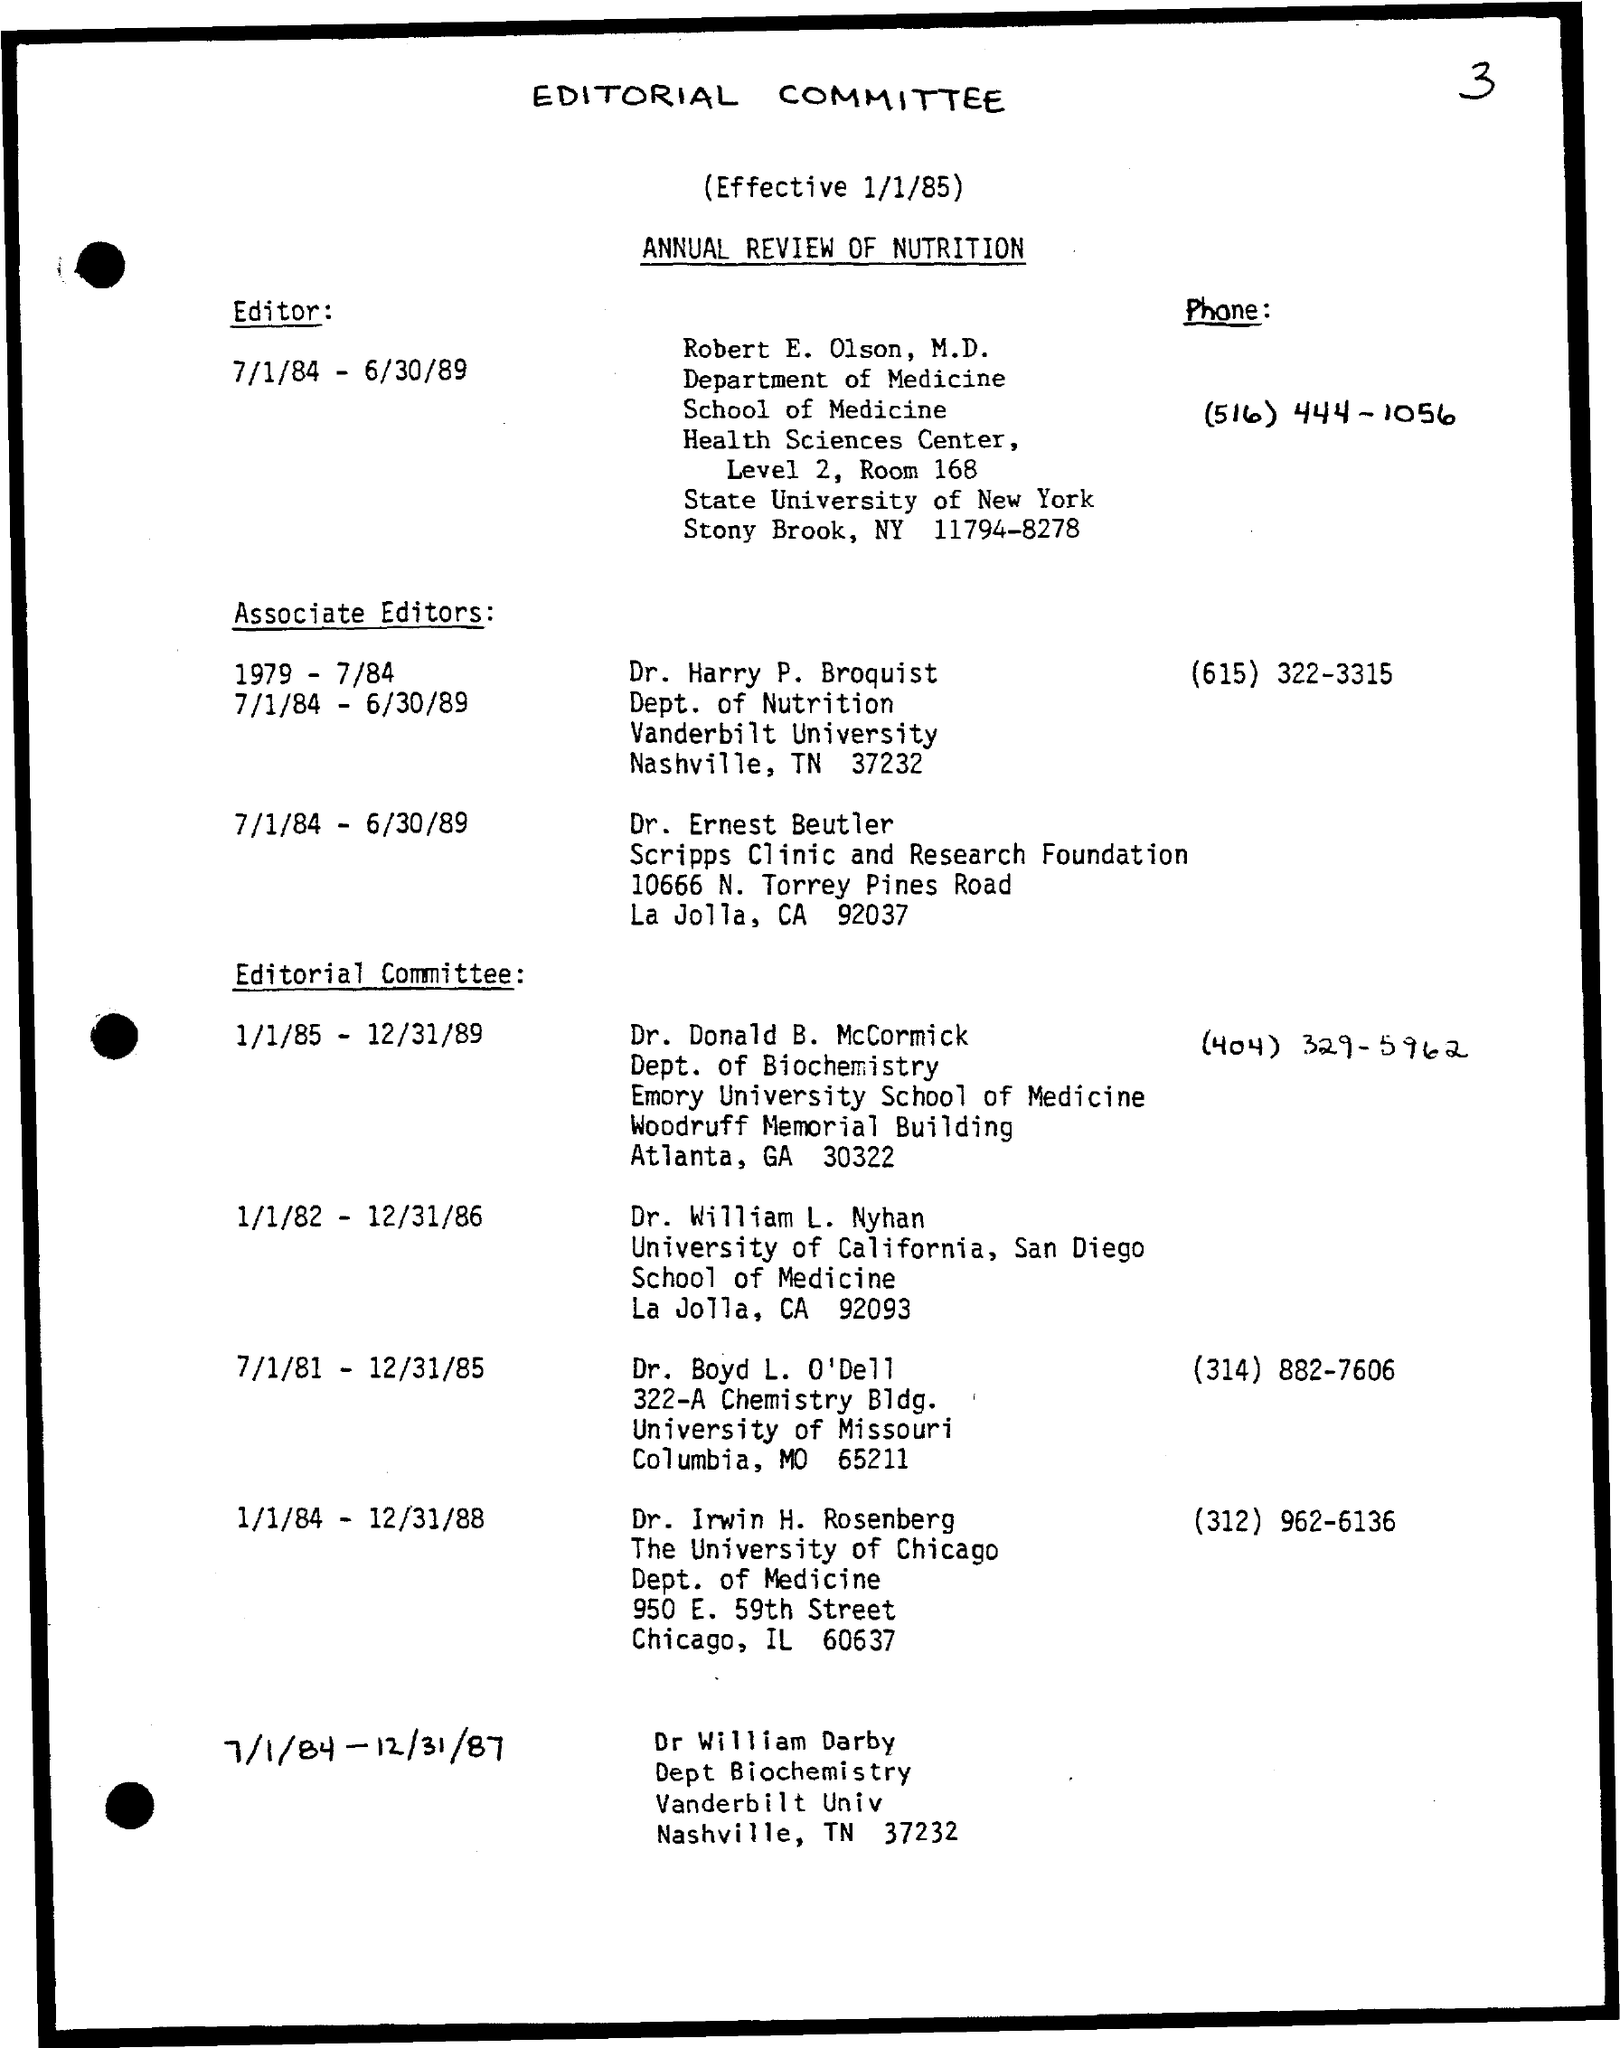Indicate a few pertinent items in this graphic. The phone number of Dr. Irwin H. Rosenberg is (312) 962-6136. Dr. Donald B. McCormick is affiliated with Emory University School of Medicine. Dr. Harry Broquist is from the department of nutrition. The committee became effective on January 1, 1985. Robert E. Olson, M.D., is the editor. 